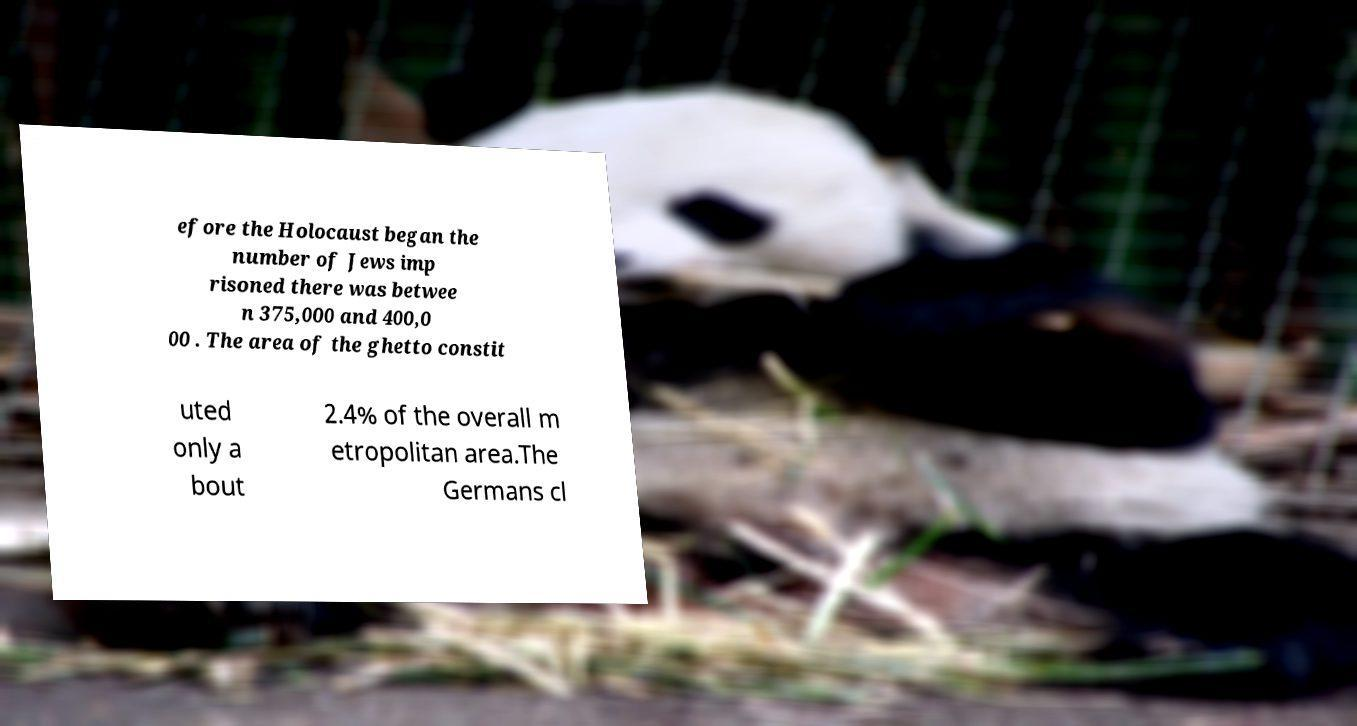There's text embedded in this image that I need extracted. Can you transcribe it verbatim? efore the Holocaust began the number of Jews imp risoned there was betwee n 375,000 and 400,0 00 . The area of the ghetto constit uted only a bout 2.4% of the overall m etropolitan area.The Germans cl 